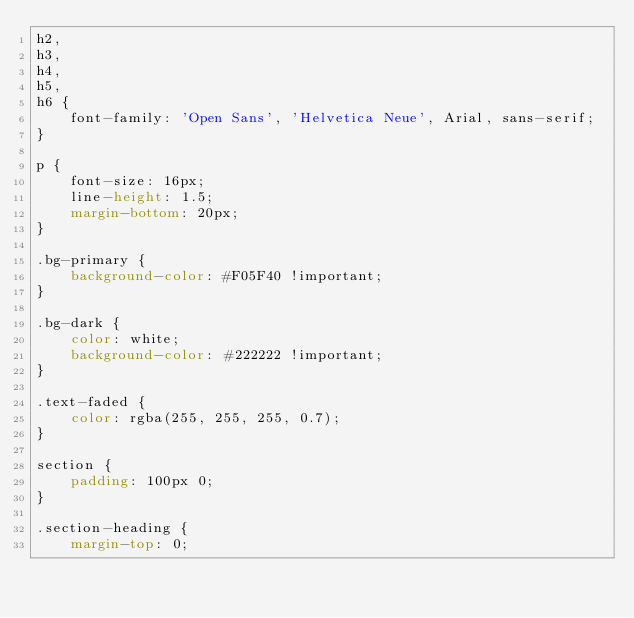Convert code to text. <code><loc_0><loc_0><loc_500><loc_500><_CSS_>h2,
h3,
h4,
h5,
h6 {
    font-family: 'Open Sans', 'Helvetica Neue', Arial, sans-serif;
}

p {
    font-size: 16px;
    line-height: 1.5;
    margin-bottom: 20px;
}

.bg-primary {
    background-color: #F05F40 !important;
}

.bg-dark {
    color: white;
    background-color: #222222 !important;
}

.text-faded {
    color: rgba(255, 255, 255, 0.7);
}

section {
    padding: 100px 0;
}

.section-heading {
    margin-top: 0;</code> 